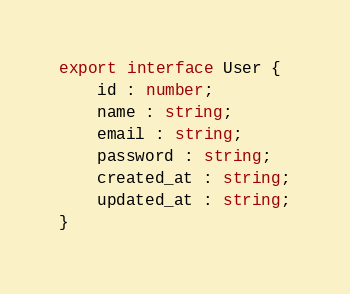Convert code to text. <code><loc_0><loc_0><loc_500><loc_500><_TypeScript_>
export interface User {
    id : number;
    name : string;
    email : string;
    password : string;
    created_at : string;
    updated_at : string;
}
</code> 